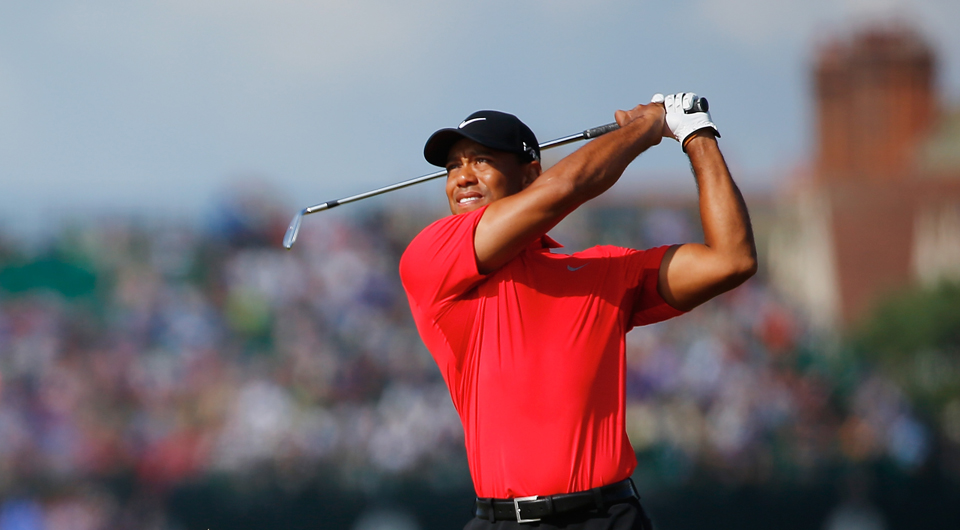Considering the crowd in the background, what does their presence indicate about the popularity or significance of the event? The presence of a large crowd in the background, despite being blurred, strongly suggests that the event is of significant popularity or importance. Large gatherings of spectators are typically seen at major golf tournaments or events featuring well-known professional golfers. The enthusiastic attendance of so many people indicates that this event is likely a professional tournament, attracting considerable interest from golf fans who are eager to witness the skill and competition on display. 